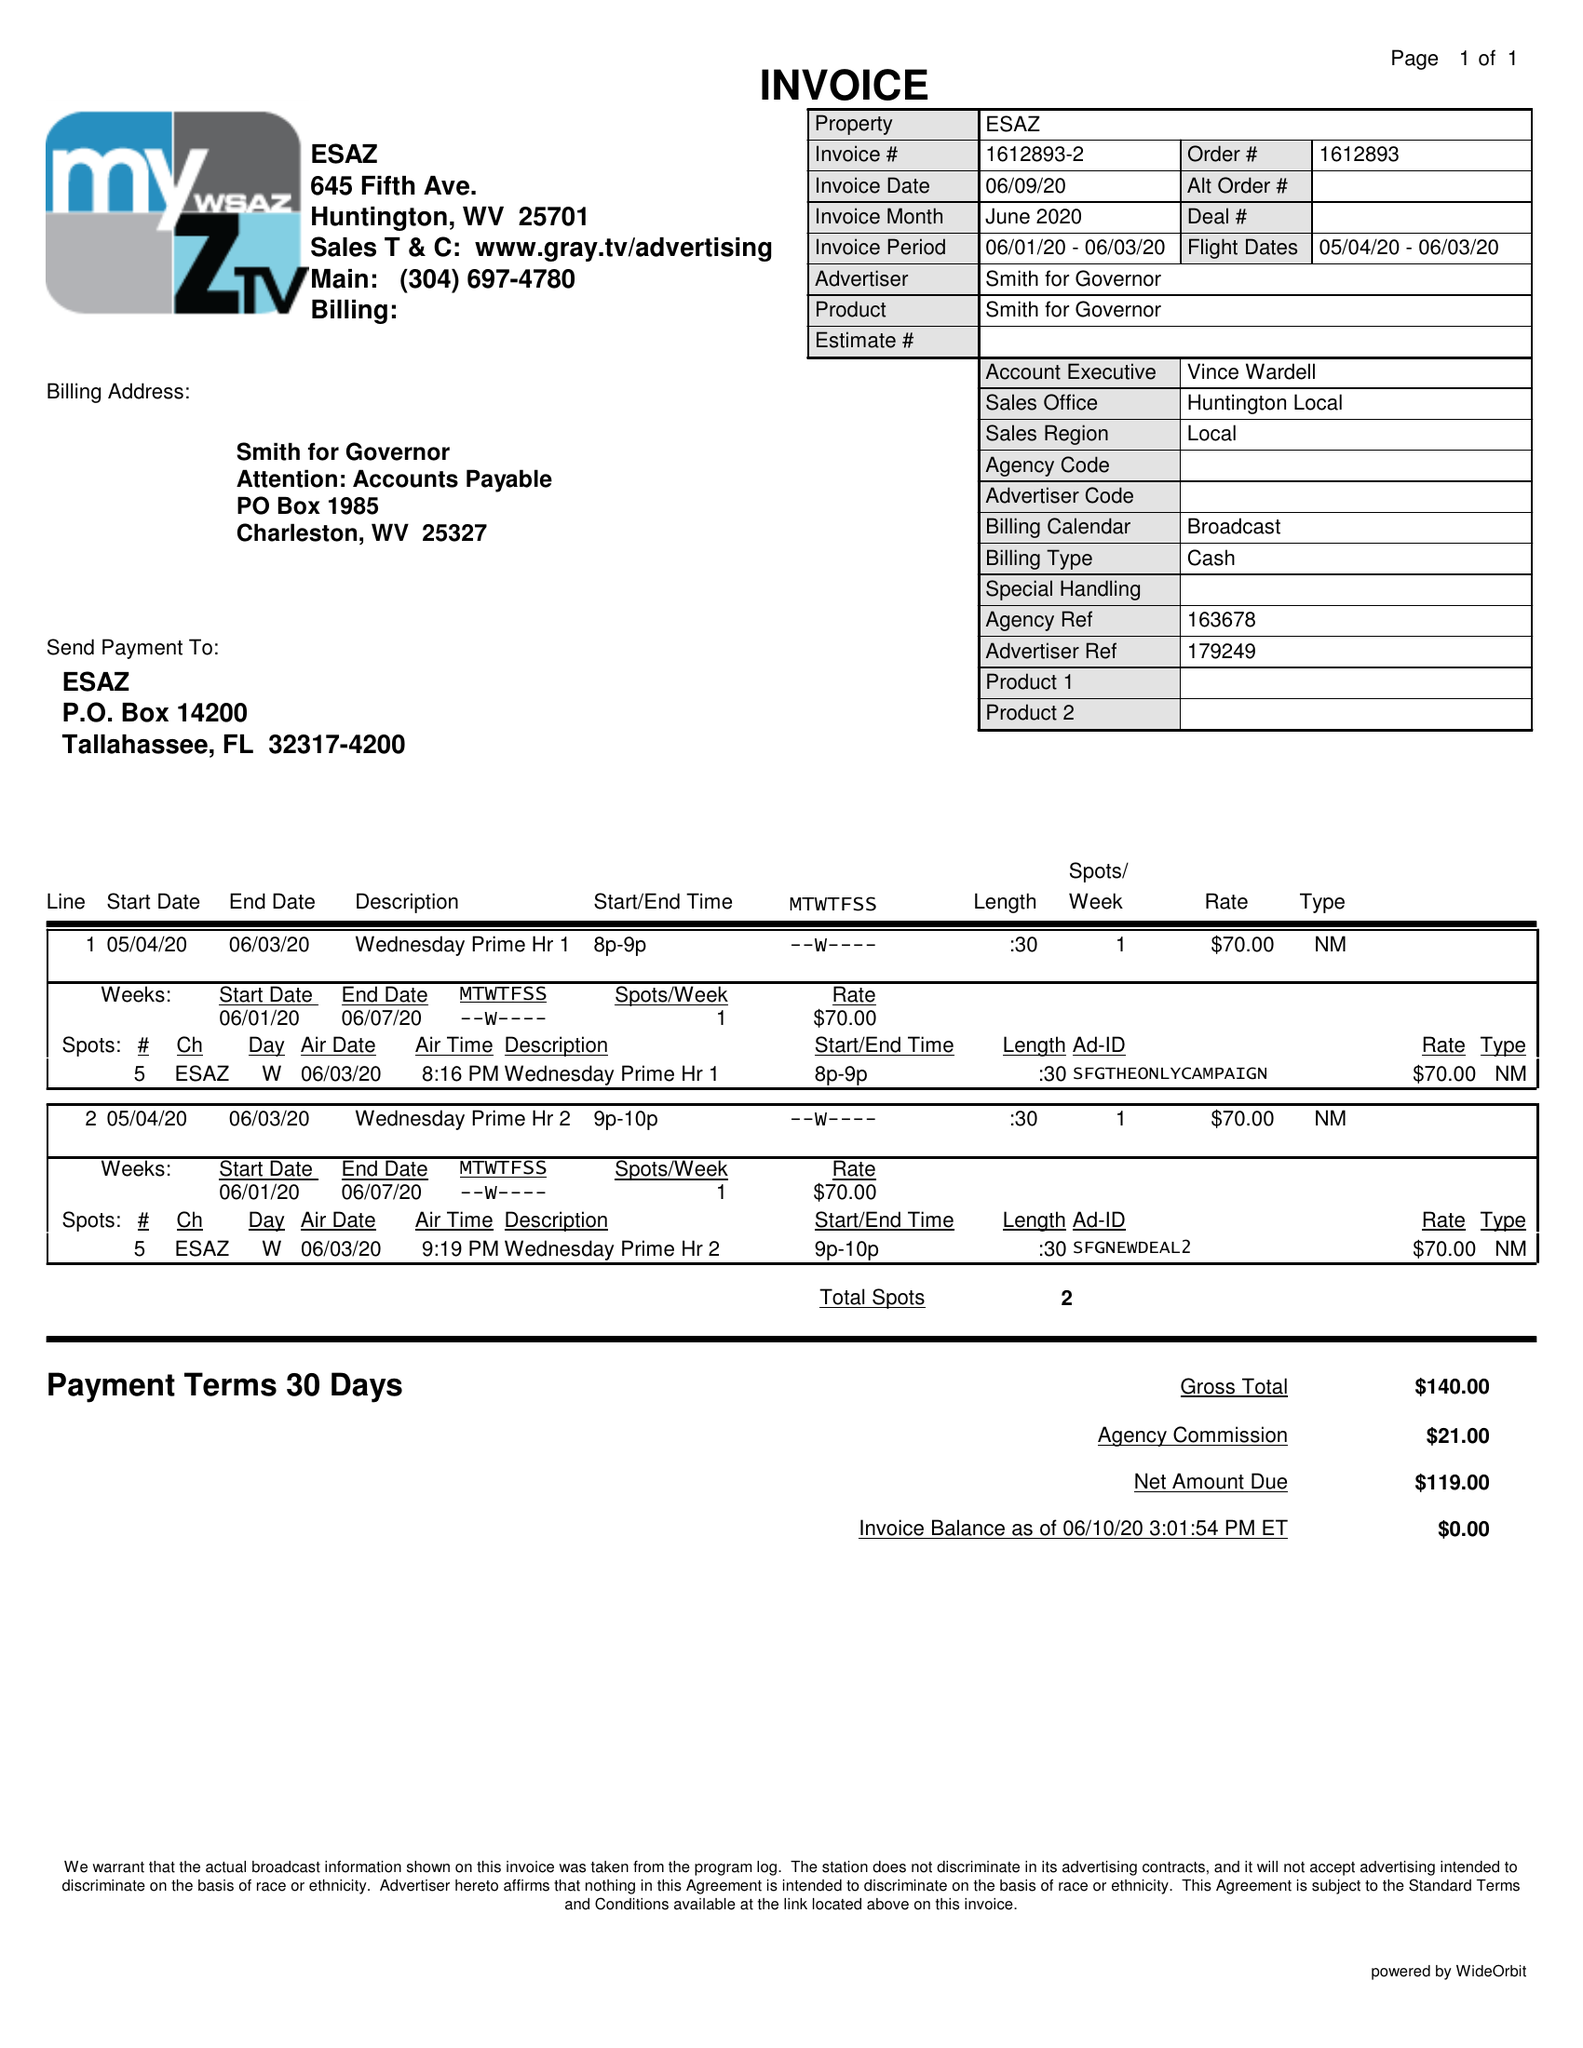What is the value for the contract_num?
Answer the question using a single word or phrase. 1612893 